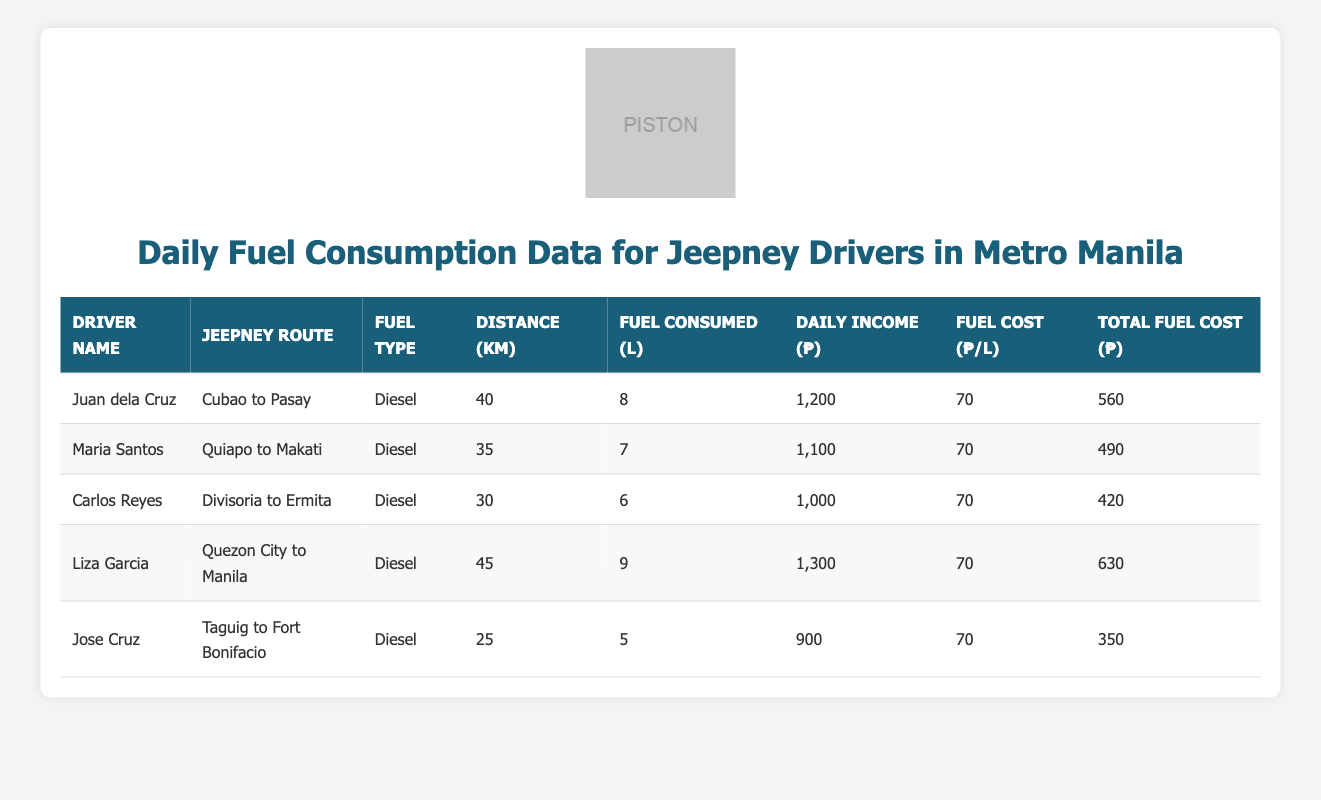What is the total distance covered by all drivers? To find the total distance, sum the distance covered by each driver: 40 + 35 + 30 + 45 + 25 = 175 km.
Answer: 175 km Who consumed the most fuel? Comparing the fuel consumed by each driver, Juan dela Cruz consumed 8 liters, which is the highest.
Answer: Juan dela Cruz What was the daily income of Liza Garcia? The table shows Liza Garcia's daily income as ₱1,300.
Answer: ₱1,300 How much did Jose Cruz spend on fuel? The total fuel cost for Jose Cruz is listed as ₱350.
Answer: ₱350 What is the average fuel cost per liter across all drivers? All drivers had a fuel cost of ₱70 per liter. Since it's consistent, the average is also ₱70.
Answer: ₱70 Who has the longest jeepney route? By comparing the distances, Liza Garcia traveled the longest distance of 45 km from Quezon City to Manila.
Answer: Liza Garcia What is the total daily income of all drivers combined? Summing their daily incomes: 1200 + 1100 + 1000 + 1300 + 900 = ₱4500.
Answer: ₱4500 Is the total fuel cost of Carlos Reyes higher than that of Maria Santos? Carlos Reyes has a total fuel cost of ₱420 while Maria Santos has ₱490. Since ₱420 is less than ₱490, the statement is false.
Answer: False What is the difference in daily income between Juan dela Cruz and Jose Cruz? Juan dela Cruz earned ₱1,200 and Jose Cruz earned ₱900. The difference is ₱1,200 - ₱900 = ₱300.
Answer: ₱300 How much fuel did the driver covering the shortest route consume? Jose Cruz, who covers 25 km, consumed 5 liters of fuel.
Answer: 5 liters What is the total fuel consumption by all drivers? Sum the fuel consumed by each driver: 8 + 7 + 6 + 9 + 5 = 35 liters.
Answer: 35 liters Which driver had the lowest daily income? Upon comparing daily incomes, Jose Cruz had the lowest income of ₱900.
Answer: Jose Cruz 